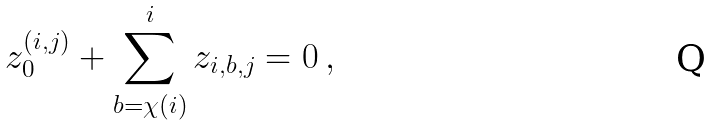Convert formula to latex. <formula><loc_0><loc_0><loc_500><loc_500>z _ { 0 } ^ { ( i , j ) } + \sum _ { b = \chi ( i ) } ^ { i } z _ { i , b , j } = 0 \, ,</formula> 